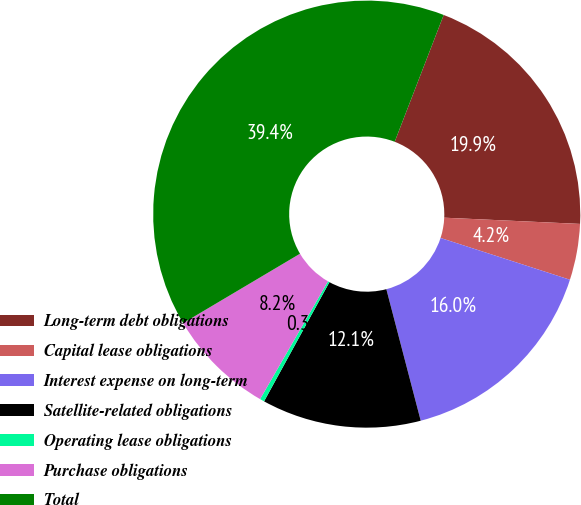<chart> <loc_0><loc_0><loc_500><loc_500><pie_chart><fcel>Long-term debt obligations<fcel>Capital lease obligations<fcel>Interest expense on long-term<fcel>Satellite-related obligations<fcel>Operating lease obligations<fcel>Purchase obligations<fcel>Total<nl><fcel>19.86%<fcel>4.24%<fcel>15.96%<fcel>12.05%<fcel>0.34%<fcel>8.15%<fcel>39.39%<nl></chart> 